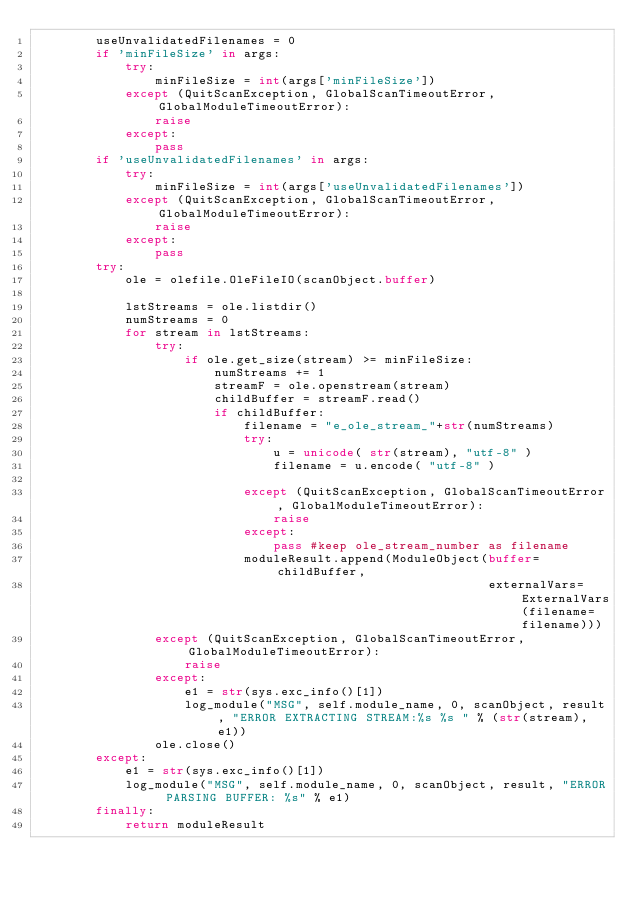<code> <loc_0><loc_0><loc_500><loc_500><_Python_>        useUnvalidatedFilenames = 0
        if 'minFileSize' in args:
            try:
                minFileSize = int(args['minFileSize'])
            except (QuitScanException, GlobalScanTimeoutError, GlobalModuleTimeoutError):
                raise
            except:
                pass 
        if 'useUnvalidatedFilenames' in args:
            try:
                minFileSize = int(args['useUnvalidatedFilenames'])
            except (QuitScanException, GlobalScanTimeoutError, GlobalModuleTimeoutError):
                raise
            except:
                pass
        try:
            ole = olefile.OleFileIO(scanObject.buffer)
            
            lstStreams = ole.listdir()
            numStreams = 0
            for stream in lstStreams:
                try:
                    if ole.get_size(stream) >= minFileSize:
                        numStreams += 1
                        streamF = ole.openstream(stream)
                        childBuffer = streamF.read()
                        if childBuffer:
                            filename = "e_ole_stream_"+str(numStreams)
                            try:
                                u = unicode( str(stream), "utf-8" )
                                filename = u.encode( "utf-8" )
                                
                            except (QuitScanException, GlobalScanTimeoutError, GlobalModuleTimeoutError):
                                raise
                            except:
                                pass #keep ole_stream_number as filename
                            moduleResult.append(ModuleObject(buffer=childBuffer, 
                                                             externalVars=ExternalVars(filename=filename)))
                except (QuitScanException, GlobalScanTimeoutError, GlobalModuleTimeoutError):
                    raise
                except:
                    e1 = str(sys.exc_info()[1])
                    log_module("MSG", self.module_name, 0, scanObject, result, "ERROR EXTRACTING STREAM:%s %s " % (str(stream), e1))
                ole.close()
        except:
            e1 = str(sys.exc_info()[1])
            log_module("MSG", self.module_name, 0, scanObject, result, "ERROR PARSING BUFFER: %s" % e1)
        finally:
            return moduleResult</code> 